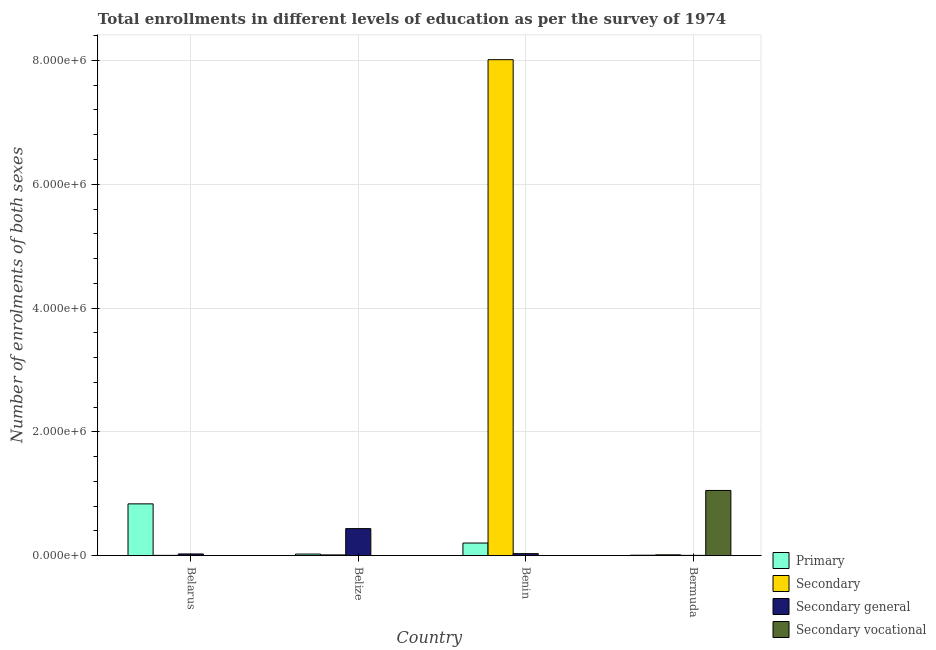How many different coloured bars are there?
Offer a terse response. 4. Are the number of bars on each tick of the X-axis equal?
Your answer should be compact. Yes. How many bars are there on the 1st tick from the left?
Ensure brevity in your answer.  4. What is the label of the 1st group of bars from the left?
Keep it short and to the point. Belarus. In how many cases, is the number of bars for a given country not equal to the number of legend labels?
Ensure brevity in your answer.  0. What is the number of enrolments in secondary education in Bermuda?
Your answer should be very brief. 1.37e+04. Across all countries, what is the maximum number of enrolments in secondary vocational education?
Make the answer very short. 1.05e+06. Across all countries, what is the minimum number of enrolments in primary education?
Give a very brief answer. 7185. In which country was the number of enrolments in primary education maximum?
Provide a short and direct response. Belarus. In which country was the number of enrolments in secondary general education minimum?
Your response must be concise. Bermuda. What is the total number of enrolments in secondary education in the graph?
Keep it short and to the point. 8.04e+06. What is the difference between the number of enrolments in primary education in Belarus and that in Bermuda?
Offer a very short reply. 8.29e+05. What is the difference between the number of enrolments in secondary general education in Benin and the number of enrolments in secondary vocational education in Belize?
Make the answer very short. 3.16e+04. What is the average number of enrolments in secondary education per country?
Ensure brevity in your answer.  2.01e+06. What is the difference between the number of enrolments in secondary education and number of enrolments in secondary vocational education in Belize?
Provide a succinct answer. 1.15e+04. In how many countries, is the number of enrolments in secondary education greater than 2400000 ?
Provide a succinct answer. 1. What is the ratio of the number of enrolments in primary education in Benin to that in Bermuda?
Your response must be concise. 28.36. What is the difference between the highest and the second highest number of enrolments in secondary vocational education?
Offer a terse response. 1.05e+06. What is the difference between the highest and the lowest number of enrolments in primary education?
Your answer should be very brief. 8.29e+05. What does the 2nd bar from the left in Belarus represents?
Your answer should be compact. Secondary. What does the 4th bar from the right in Belarus represents?
Provide a succinct answer. Primary. Is it the case that in every country, the sum of the number of enrolments in primary education and number of enrolments in secondary education is greater than the number of enrolments in secondary general education?
Provide a succinct answer. No. Are all the bars in the graph horizontal?
Your answer should be compact. No. How many legend labels are there?
Offer a very short reply. 4. How are the legend labels stacked?
Offer a very short reply. Vertical. What is the title of the graph?
Provide a short and direct response. Total enrollments in different levels of education as per the survey of 1974. What is the label or title of the Y-axis?
Offer a terse response. Number of enrolments of both sexes. What is the Number of enrolments of both sexes of Primary in Belarus?
Provide a succinct answer. 8.37e+05. What is the Number of enrolments of both sexes of Secondary in Belarus?
Offer a terse response. 4539. What is the Number of enrolments of both sexes in Secondary general in Belarus?
Keep it short and to the point. 2.76e+04. What is the Number of enrolments of both sexes in Secondary vocational in Belarus?
Ensure brevity in your answer.  1049. What is the Number of enrolments of both sexes of Primary in Belize?
Your answer should be compact. 2.59e+04. What is the Number of enrolments of both sexes of Secondary in Belize?
Keep it short and to the point. 1.22e+04. What is the Number of enrolments of both sexes in Secondary general in Belize?
Provide a short and direct response. 4.37e+05. What is the Number of enrolments of both sexes of Secondary vocational in Belize?
Make the answer very short. 734. What is the Number of enrolments of both sexes in Primary in Benin?
Your answer should be very brief. 2.04e+05. What is the Number of enrolments of both sexes of Secondary in Benin?
Ensure brevity in your answer.  8.01e+06. What is the Number of enrolments of both sexes in Secondary general in Benin?
Offer a terse response. 3.23e+04. What is the Number of enrolments of both sexes in Secondary vocational in Benin?
Your answer should be very brief. 1937. What is the Number of enrolments of both sexes of Primary in Bermuda?
Provide a succinct answer. 7185. What is the Number of enrolments of both sexes of Secondary in Bermuda?
Provide a succinct answer. 1.37e+04. What is the Number of enrolments of both sexes in Secondary general in Bermuda?
Your answer should be compact. 4539. What is the Number of enrolments of both sexes of Secondary vocational in Bermuda?
Offer a very short reply. 1.05e+06. Across all countries, what is the maximum Number of enrolments of both sexes in Primary?
Your answer should be compact. 8.37e+05. Across all countries, what is the maximum Number of enrolments of both sexes in Secondary?
Keep it short and to the point. 8.01e+06. Across all countries, what is the maximum Number of enrolments of both sexes in Secondary general?
Give a very brief answer. 4.37e+05. Across all countries, what is the maximum Number of enrolments of both sexes of Secondary vocational?
Provide a short and direct response. 1.05e+06. Across all countries, what is the minimum Number of enrolments of both sexes of Primary?
Offer a very short reply. 7185. Across all countries, what is the minimum Number of enrolments of both sexes in Secondary?
Your answer should be very brief. 4539. Across all countries, what is the minimum Number of enrolments of both sexes of Secondary general?
Keep it short and to the point. 4539. Across all countries, what is the minimum Number of enrolments of both sexes of Secondary vocational?
Give a very brief answer. 734. What is the total Number of enrolments of both sexes of Primary in the graph?
Keep it short and to the point. 1.07e+06. What is the total Number of enrolments of both sexes of Secondary in the graph?
Your response must be concise. 8.04e+06. What is the total Number of enrolments of both sexes of Secondary general in the graph?
Keep it short and to the point. 5.01e+05. What is the total Number of enrolments of both sexes in Secondary vocational in the graph?
Your answer should be very brief. 1.06e+06. What is the difference between the Number of enrolments of both sexes in Primary in Belarus and that in Belize?
Give a very brief answer. 8.11e+05. What is the difference between the Number of enrolments of both sexes in Secondary in Belarus and that in Belize?
Provide a short and direct response. -7706. What is the difference between the Number of enrolments of both sexes in Secondary general in Belarus and that in Belize?
Give a very brief answer. -4.09e+05. What is the difference between the Number of enrolments of both sexes in Secondary vocational in Belarus and that in Belize?
Give a very brief answer. 315. What is the difference between the Number of enrolments of both sexes of Primary in Belarus and that in Benin?
Your answer should be very brief. 6.33e+05. What is the difference between the Number of enrolments of both sexes of Secondary in Belarus and that in Benin?
Ensure brevity in your answer.  -8.01e+06. What is the difference between the Number of enrolments of both sexes of Secondary general in Belarus and that in Benin?
Offer a very short reply. -4763. What is the difference between the Number of enrolments of both sexes of Secondary vocational in Belarus and that in Benin?
Offer a terse response. -888. What is the difference between the Number of enrolments of both sexes in Primary in Belarus and that in Bermuda?
Make the answer very short. 8.29e+05. What is the difference between the Number of enrolments of both sexes of Secondary in Belarus and that in Bermuda?
Make the answer very short. -9165. What is the difference between the Number of enrolments of both sexes of Secondary general in Belarus and that in Bermuda?
Offer a terse response. 2.30e+04. What is the difference between the Number of enrolments of both sexes in Secondary vocational in Belarus and that in Bermuda?
Give a very brief answer. -1.05e+06. What is the difference between the Number of enrolments of both sexes of Primary in Belize and that in Benin?
Your response must be concise. -1.78e+05. What is the difference between the Number of enrolments of both sexes in Secondary in Belize and that in Benin?
Give a very brief answer. -8.00e+06. What is the difference between the Number of enrolments of both sexes of Secondary general in Belize and that in Benin?
Give a very brief answer. 4.04e+05. What is the difference between the Number of enrolments of both sexes in Secondary vocational in Belize and that in Benin?
Keep it short and to the point. -1203. What is the difference between the Number of enrolments of both sexes in Primary in Belize and that in Bermuda?
Offer a terse response. 1.87e+04. What is the difference between the Number of enrolments of both sexes in Secondary in Belize and that in Bermuda?
Keep it short and to the point. -1459. What is the difference between the Number of enrolments of both sexes of Secondary general in Belize and that in Bermuda?
Provide a short and direct response. 4.32e+05. What is the difference between the Number of enrolments of both sexes of Secondary vocational in Belize and that in Bermuda?
Keep it short and to the point. -1.05e+06. What is the difference between the Number of enrolments of both sexes in Primary in Benin and that in Bermuda?
Provide a succinct answer. 1.97e+05. What is the difference between the Number of enrolments of both sexes of Secondary in Benin and that in Bermuda?
Offer a terse response. 8.00e+06. What is the difference between the Number of enrolments of both sexes of Secondary general in Benin and that in Bermuda?
Your answer should be compact. 2.78e+04. What is the difference between the Number of enrolments of both sexes in Secondary vocational in Benin and that in Bermuda?
Your answer should be very brief. -1.05e+06. What is the difference between the Number of enrolments of both sexes in Primary in Belarus and the Number of enrolments of both sexes in Secondary in Belize?
Give a very brief answer. 8.24e+05. What is the difference between the Number of enrolments of both sexes in Primary in Belarus and the Number of enrolments of both sexes in Secondary general in Belize?
Your answer should be very brief. 4.00e+05. What is the difference between the Number of enrolments of both sexes of Primary in Belarus and the Number of enrolments of both sexes of Secondary vocational in Belize?
Make the answer very short. 8.36e+05. What is the difference between the Number of enrolments of both sexes in Secondary in Belarus and the Number of enrolments of both sexes in Secondary general in Belize?
Provide a succinct answer. -4.32e+05. What is the difference between the Number of enrolments of both sexes in Secondary in Belarus and the Number of enrolments of both sexes in Secondary vocational in Belize?
Ensure brevity in your answer.  3805. What is the difference between the Number of enrolments of both sexes of Secondary general in Belarus and the Number of enrolments of both sexes of Secondary vocational in Belize?
Provide a succinct answer. 2.69e+04. What is the difference between the Number of enrolments of both sexes in Primary in Belarus and the Number of enrolments of both sexes in Secondary in Benin?
Your response must be concise. -7.18e+06. What is the difference between the Number of enrolments of both sexes in Primary in Belarus and the Number of enrolments of both sexes in Secondary general in Benin?
Give a very brief answer. 8.04e+05. What is the difference between the Number of enrolments of both sexes of Primary in Belarus and the Number of enrolments of both sexes of Secondary vocational in Benin?
Your answer should be compact. 8.35e+05. What is the difference between the Number of enrolments of both sexes of Secondary in Belarus and the Number of enrolments of both sexes of Secondary general in Benin?
Offer a terse response. -2.78e+04. What is the difference between the Number of enrolments of both sexes in Secondary in Belarus and the Number of enrolments of both sexes in Secondary vocational in Benin?
Your response must be concise. 2602. What is the difference between the Number of enrolments of both sexes in Secondary general in Belarus and the Number of enrolments of both sexes in Secondary vocational in Benin?
Keep it short and to the point. 2.56e+04. What is the difference between the Number of enrolments of both sexes of Primary in Belarus and the Number of enrolments of both sexes of Secondary in Bermuda?
Offer a terse response. 8.23e+05. What is the difference between the Number of enrolments of both sexes of Primary in Belarus and the Number of enrolments of both sexes of Secondary general in Bermuda?
Provide a succinct answer. 8.32e+05. What is the difference between the Number of enrolments of both sexes of Primary in Belarus and the Number of enrolments of both sexes of Secondary vocational in Bermuda?
Your response must be concise. -2.17e+05. What is the difference between the Number of enrolments of both sexes in Secondary in Belarus and the Number of enrolments of both sexes in Secondary general in Bermuda?
Keep it short and to the point. 0. What is the difference between the Number of enrolments of both sexes in Secondary in Belarus and the Number of enrolments of both sexes in Secondary vocational in Bermuda?
Provide a succinct answer. -1.05e+06. What is the difference between the Number of enrolments of both sexes of Secondary general in Belarus and the Number of enrolments of both sexes of Secondary vocational in Bermuda?
Provide a succinct answer. -1.03e+06. What is the difference between the Number of enrolments of both sexes in Primary in Belize and the Number of enrolments of both sexes in Secondary in Benin?
Give a very brief answer. -7.99e+06. What is the difference between the Number of enrolments of both sexes of Primary in Belize and the Number of enrolments of both sexes of Secondary general in Benin?
Give a very brief answer. -6447. What is the difference between the Number of enrolments of both sexes in Primary in Belize and the Number of enrolments of both sexes in Secondary vocational in Benin?
Your answer should be very brief. 2.40e+04. What is the difference between the Number of enrolments of both sexes of Secondary in Belize and the Number of enrolments of both sexes of Secondary general in Benin?
Make the answer very short. -2.01e+04. What is the difference between the Number of enrolments of both sexes in Secondary in Belize and the Number of enrolments of both sexes in Secondary vocational in Benin?
Provide a succinct answer. 1.03e+04. What is the difference between the Number of enrolments of both sexes of Secondary general in Belize and the Number of enrolments of both sexes of Secondary vocational in Benin?
Your response must be concise. 4.35e+05. What is the difference between the Number of enrolments of both sexes of Primary in Belize and the Number of enrolments of both sexes of Secondary in Bermuda?
Your answer should be compact. 1.22e+04. What is the difference between the Number of enrolments of both sexes in Primary in Belize and the Number of enrolments of both sexes in Secondary general in Bermuda?
Offer a terse response. 2.14e+04. What is the difference between the Number of enrolments of both sexes in Primary in Belize and the Number of enrolments of both sexes in Secondary vocational in Bermuda?
Make the answer very short. -1.03e+06. What is the difference between the Number of enrolments of both sexes of Secondary in Belize and the Number of enrolments of both sexes of Secondary general in Bermuda?
Provide a short and direct response. 7706. What is the difference between the Number of enrolments of both sexes in Secondary in Belize and the Number of enrolments of both sexes in Secondary vocational in Bermuda?
Your response must be concise. -1.04e+06. What is the difference between the Number of enrolments of both sexes of Secondary general in Belize and the Number of enrolments of both sexes of Secondary vocational in Bermuda?
Your response must be concise. -6.17e+05. What is the difference between the Number of enrolments of both sexes in Primary in Benin and the Number of enrolments of both sexes in Secondary in Bermuda?
Your answer should be compact. 1.90e+05. What is the difference between the Number of enrolments of both sexes of Primary in Benin and the Number of enrolments of both sexes of Secondary general in Bermuda?
Your response must be concise. 1.99e+05. What is the difference between the Number of enrolments of both sexes of Primary in Benin and the Number of enrolments of both sexes of Secondary vocational in Bermuda?
Provide a succinct answer. -8.50e+05. What is the difference between the Number of enrolments of both sexes of Secondary in Benin and the Number of enrolments of both sexes of Secondary general in Bermuda?
Ensure brevity in your answer.  8.01e+06. What is the difference between the Number of enrolments of both sexes of Secondary in Benin and the Number of enrolments of both sexes of Secondary vocational in Bermuda?
Your response must be concise. 6.96e+06. What is the difference between the Number of enrolments of both sexes of Secondary general in Benin and the Number of enrolments of both sexes of Secondary vocational in Bermuda?
Your answer should be compact. -1.02e+06. What is the average Number of enrolments of both sexes of Primary per country?
Make the answer very short. 2.68e+05. What is the average Number of enrolments of both sexes in Secondary per country?
Your answer should be compact. 2.01e+06. What is the average Number of enrolments of both sexes of Secondary general per country?
Make the answer very short. 1.25e+05. What is the average Number of enrolments of both sexes in Secondary vocational per country?
Keep it short and to the point. 2.64e+05. What is the difference between the Number of enrolments of both sexes in Primary and Number of enrolments of both sexes in Secondary in Belarus?
Provide a short and direct response. 8.32e+05. What is the difference between the Number of enrolments of both sexes of Primary and Number of enrolments of both sexes of Secondary general in Belarus?
Your answer should be very brief. 8.09e+05. What is the difference between the Number of enrolments of both sexes in Primary and Number of enrolments of both sexes in Secondary vocational in Belarus?
Provide a succinct answer. 8.36e+05. What is the difference between the Number of enrolments of both sexes of Secondary and Number of enrolments of both sexes of Secondary general in Belarus?
Make the answer very short. -2.30e+04. What is the difference between the Number of enrolments of both sexes in Secondary and Number of enrolments of both sexes in Secondary vocational in Belarus?
Ensure brevity in your answer.  3490. What is the difference between the Number of enrolments of both sexes in Secondary general and Number of enrolments of both sexes in Secondary vocational in Belarus?
Your answer should be compact. 2.65e+04. What is the difference between the Number of enrolments of both sexes in Primary and Number of enrolments of both sexes in Secondary in Belize?
Your answer should be very brief. 1.37e+04. What is the difference between the Number of enrolments of both sexes of Primary and Number of enrolments of both sexes of Secondary general in Belize?
Provide a short and direct response. -4.11e+05. What is the difference between the Number of enrolments of both sexes of Primary and Number of enrolments of both sexes of Secondary vocational in Belize?
Make the answer very short. 2.52e+04. What is the difference between the Number of enrolments of both sexes of Secondary and Number of enrolments of both sexes of Secondary general in Belize?
Offer a terse response. -4.25e+05. What is the difference between the Number of enrolments of both sexes of Secondary and Number of enrolments of both sexes of Secondary vocational in Belize?
Your answer should be very brief. 1.15e+04. What is the difference between the Number of enrolments of both sexes of Secondary general and Number of enrolments of both sexes of Secondary vocational in Belize?
Offer a very short reply. 4.36e+05. What is the difference between the Number of enrolments of both sexes of Primary and Number of enrolments of both sexes of Secondary in Benin?
Provide a short and direct response. -7.81e+06. What is the difference between the Number of enrolments of both sexes in Primary and Number of enrolments of both sexes in Secondary general in Benin?
Your response must be concise. 1.71e+05. What is the difference between the Number of enrolments of both sexes in Primary and Number of enrolments of both sexes in Secondary vocational in Benin?
Offer a very short reply. 2.02e+05. What is the difference between the Number of enrolments of both sexes in Secondary and Number of enrolments of both sexes in Secondary general in Benin?
Offer a very short reply. 7.98e+06. What is the difference between the Number of enrolments of both sexes of Secondary and Number of enrolments of both sexes of Secondary vocational in Benin?
Your answer should be very brief. 8.01e+06. What is the difference between the Number of enrolments of both sexes in Secondary general and Number of enrolments of both sexes in Secondary vocational in Benin?
Offer a terse response. 3.04e+04. What is the difference between the Number of enrolments of both sexes of Primary and Number of enrolments of both sexes of Secondary in Bermuda?
Ensure brevity in your answer.  -6519. What is the difference between the Number of enrolments of both sexes in Primary and Number of enrolments of both sexes in Secondary general in Bermuda?
Your answer should be compact. 2646. What is the difference between the Number of enrolments of both sexes of Primary and Number of enrolments of both sexes of Secondary vocational in Bermuda?
Give a very brief answer. -1.05e+06. What is the difference between the Number of enrolments of both sexes of Secondary and Number of enrolments of both sexes of Secondary general in Bermuda?
Provide a short and direct response. 9165. What is the difference between the Number of enrolments of both sexes of Secondary and Number of enrolments of both sexes of Secondary vocational in Bermuda?
Your answer should be very brief. -1.04e+06. What is the difference between the Number of enrolments of both sexes in Secondary general and Number of enrolments of both sexes in Secondary vocational in Bermuda?
Provide a short and direct response. -1.05e+06. What is the ratio of the Number of enrolments of both sexes of Primary in Belarus to that in Belize?
Ensure brevity in your answer.  32.3. What is the ratio of the Number of enrolments of both sexes of Secondary in Belarus to that in Belize?
Give a very brief answer. 0.37. What is the ratio of the Number of enrolments of both sexes in Secondary general in Belarus to that in Belize?
Provide a short and direct response. 0.06. What is the ratio of the Number of enrolments of both sexes of Secondary vocational in Belarus to that in Belize?
Keep it short and to the point. 1.43. What is the ratio of the Number of enrolments of both sexes in Primary in Belarus to that in Benin?
Offer a very short reply. 4.11. What is the ratio of the Number of enrolments of both sexes of Secondary in Belarus to that in Benin?
Your answer should be very brief. 0. What is the ratio of the Number of enrolments of both sexes of Secondary general in Belarus to that in Benin?
Offer a terse response. 0.85. What is the ratio of the Number of enrolments of both sexes of Secondary vocational in Belarus to that in Benin?
Make the answer very short. 0.54. What is the ratio of the Number of enrolments of both sexes of Primary in Belarus to that in Bermuda?
Your answer should be compact. 116.44. What is the ratio of the Number of enrolments of both sexes in Secondary in Belarus to that in Bermuda?
Your answer should be very brief. 0.33. What is the ratio of the Number of enrolments of both sexes of Secondary general in Belarus to that in Bermuda?
Keep it short and to the point. 6.08. What is the ratio of the Number of enrolments of both sexes in Secondary vocational in Belarus to that in Bermuda?
Make the answer very short. 0. What is the ratio of the Number of enrolments of both sexes in Primary in Belize to that in Benin?
Give a very brief answer. 0.13. What is the ratio of the Number of enrolments of both sexes of Secondary in Belize to that in Benin?
Offer a very short reply. 0. What is the ratio of the Number of enrolments of both sexes of Secondary general in Belize to that in Benin?
Keep it short and to the point. 13.5. What is the ratio of the Number of enrolments of both sexes of Secondary vocational in Belize to that in Benin?
Your answer should be very brief. 0.38. What is the ratio of the Number of enrolments of both sexes in Primary in Belize to that in Bermuda?
Keep it short and to the point. 3.6. What is the ratio of the Number of enrolments of both sexes in Secondary in Belize to that in Bermuda?
Keep it short and to the point. 0.89. What is the ratio of the Number of enrolments of both sexes in Secondary general in Belize to that in Bermuda?
Provide a short and direct response. 96.24. What is the ratio of the Number of enrolments of both sexes in Secondary vocational in Belize to that in Bermuda?
Offer a terse response. 0. What is the ratio of the Number of enrolments of both sexes of Primary in Benin to that in Bermuda?
Keep it short and to the point. 28.36. What is the ratio of the Number of enrolments of both sexes of Secondary in Benin to that in Bermuda?
Your answer should be compact. 584.68. What is the ratio of the Number of enrolments of both sexes of Secondary general in Benin to that in Bermuda?
Your answer should be compact. 7.13. What is the ratio of the Number of enrolments of both sexes of Secondary vocational in Benin to that in Bermuda?
Offer a very short reply. 0. What is the difference between the highest and the second highest Number of enrolments of both sexes of Primary?
Ensure brevity in your answer.  6.33e+05. What is the difference between the highest and the second highest Number of enrolments of both sexes of Secondary?
Keep it short and to the point. 8.00e+06. What is the difference between the highest and the second highest Number of enrolments of both sexes of Secondary general?
Provide a succinct answer. 4.04e+05. What is the difference between the highest and the second highest Number of enrolments of both sexes of Secondary vocational?
Your response must be concise. 1.05e+06. What is the difference between the highest and the lowest Number of enrolments of both sexes in Primary?
Offer a very short reply. 8.29e+05. What is the difference between the highest and the lowest Number of enrolments of both sexes of Secondary?
Give a very brief answer. 8.01e+06. What is the difference between the highest and the lowest Number of enrolments of both sexes of Secondary general?
Ensure brevity in your answer.  4.32e+05. What is the difference between the highest and the lowest Number of enrolments of both sexes of Secondary vocational?
Keep it short and to the point. 1.05e+06. 